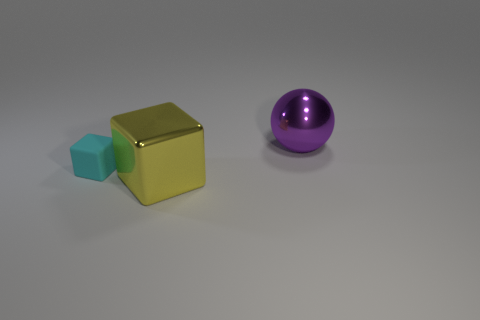Add 3 big shiny cubes. How many objects exist? 6 Subtract all yellow cubes. How many cubes are left? 1 Subtract 1 spheres. How many spheres are left? 0 Subtract all cubes. How many objects are left? 1 Subtract all brown cubes. Subtract all yellow cylinders. How many cubes are left? 2 Subtract all brown cubes. How many brown balls are left? 0 Subtract all yellow metal objects. Subtract all big metallic objects. How many objects are left? 0 Add 1 small matte blocks. How many small matte blocks are left? 2 Add 2 big yellow rubber cubes. How many big yellow rubber cubes exist? 2 Subtract 0 cyan cylinders. How many objects are left? 3 